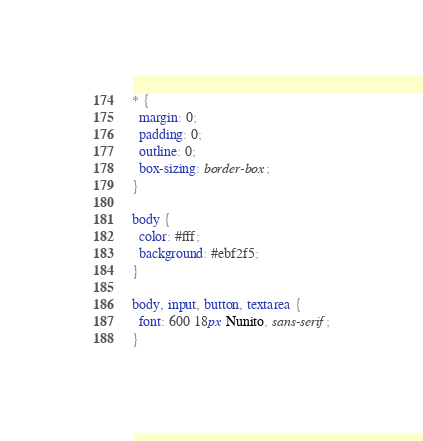Convert code to text. <code><loc_0><loc_0><loc_500><loc_500><_CSS_>* {
  margin: 0;
  padding: 0;
  outline: 0;
  box-sizing: border-box;
}

body {
  color: #fff;
  background: #ebf2f5;
}

body, input, button, textarea {
  font: 600 18px Nunito, sans-serif;
}
</code> 